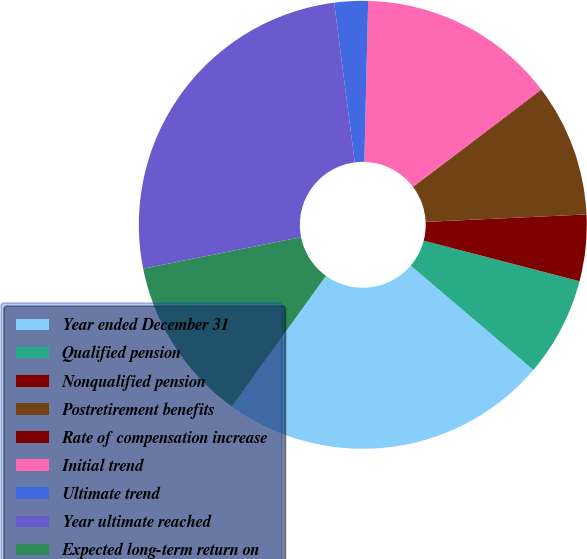Convert chart. <chart><loc_0><loc_0><loc_500><loc_500><pie_chart><fcel>Year ended December 31<fcel>Qualified pension<fcel>Nonqualified pension<fcel>Postretirement benefits<fcel>Rate of compensation increase<fcel>Initial trend<fcel>Ultimate trend<fcel>Year ultimate reached<fcel>Expected long-term return on<nl><fcel>23.72%<fcel>7.17%<fcel>4.79%<fcel>9.54%<fcel>0.05%<fcel>14.29%<fcel>2.42%<fcel>26.1%<fcel>11.92%<nl></chart> 